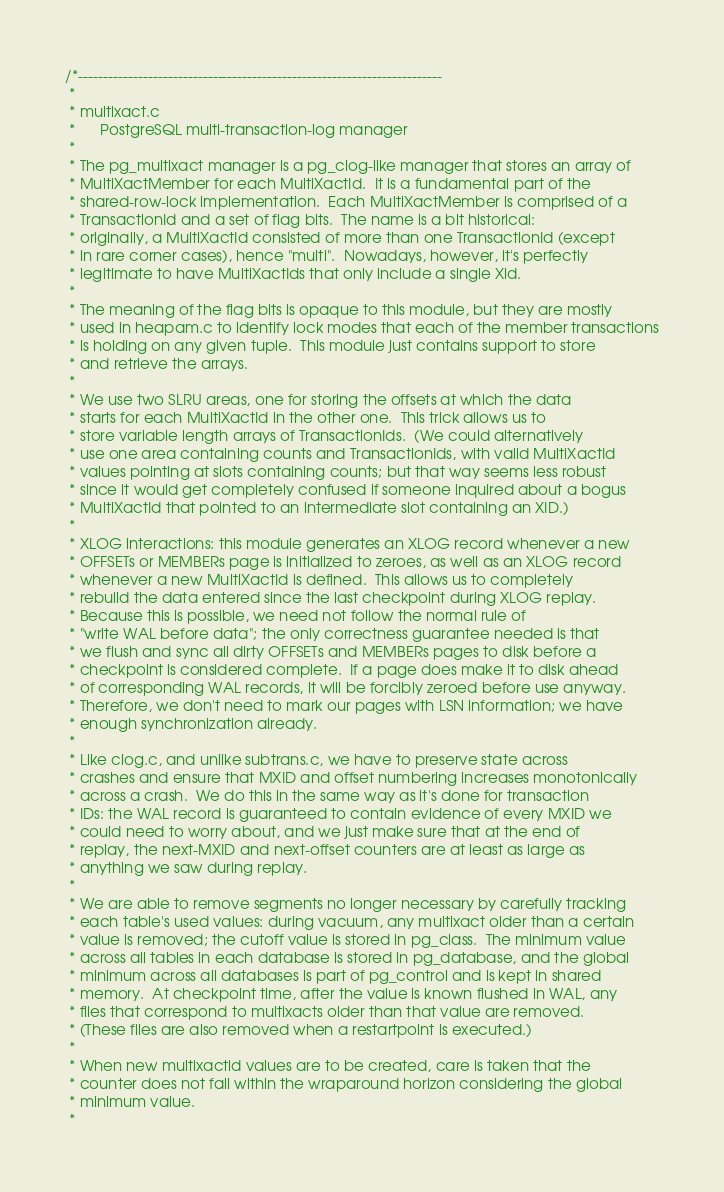<code> <loc_0><loc_0><loc_500><loc_500><_C_>/*-------------------------------------------------------------------------
 *
 * multixact.c
 *		PostgreSQL multi-transaction-log manager
 *
 * The pg_multixact manager is a pg_clog-like manager that stores an array of
 * MultiXactMember for each MultiXactId.  It is a fundamental part of the
 * shared-row-lock implementation.  Each MultiXactMember is comprised of a
 * TransactionId and a set of flag bits.  The name is a bit historical:
 * originally, a MultiXactId consisted of more than one TransactionId (except
 * in rare corner cases), hence "multi".  Nowadays, however, it's perfectly
 * legitimate to have MultiXactIds that only include a single Xid.
 *
 * The meaning of the flag bits is opaque to this module, but they are mostly
 * used in heapam.c to identify lock modes that each of the member transactions
 * is holding on any given tuple.  This module just contains support to store
 * and retrieve the arrays.
 *
 * We use two SLRU areas, one for storing the offsets at which the data
 * starts for each MultiXactId in the other one.  This trick allows us to
 * store variable length arrays of TransactionIds.  (We could alternatively
 * use one area containing counts and TransactionIds, with valid MultiXactId
 * values pointing at slots containing counts; but that way seems less robust
 * since it would get completely confused if someone inquired about a bogus
 * MultiXactId that pointed to an intermediate slot containing an XID.)
 *
 * XLOG interactions: this module generates an XLOG record whenever a new
 * OFFSETs or MEMBERs page is initialized to zeroes, as well as an XLOG record
 * whenever a new MultiXactId is defined.  This allows us to completely
 * rebuild the data entered since the last checkpoint during XLOG replay.
 * Because this is possible, we need not follow the normal rule of
 * "write WAL before data"; the only correctness guarantee needed is that
 * we flush and sync all dirty OFFSETs and MEMBERs pages to disk before a
 * checkpoint is considered complete.  If a page does make it to disk ahead
 * of corresponding WAL records, it will be forcibly zeroed before use anyway.
 * Therefore, we don't need to mark our pages with LSN information; we have
 * enough synchronization already.
 *
 * Like clog.c, and unlike subtrans.c, we have to preserve state across
 * crashes and ensure that MXID and offset numbering increases monotonically
 * across a crash.  We do this in the same way as it's done for transaction
 * IDs: the WAL record is guaranteed to contain evidence of every MXID we
 * could need to worry about, and we just make sure that at the end of
 * replay, the next-MXID and next-offset counters are at least as large as
 * anything we saw during replay.
 *
 * We are able to remove segments no longer necessary by carefully tracking
 * each table's used values: during vacuum, any multixact older than a certain
 * value is removed; the cutoff value is stored in pg_class.  The minimum value
 * across all tables in each database is stored in pg_database, and the global
 * minimum across all databases is part of pg_control and is kept in shared
 * memory.  At checkpoint time, after the value is known flushed in WAL, any
 * files that correspond to multixacts older than that value are removed.
 * (These files are also removed when a restartpoint is executed.)
 *
 * When new multixactid values are to be created, care is taken that the
 * counter does not fall within the wraparound horizon considering the global
 * minimum value.
 *</code> 